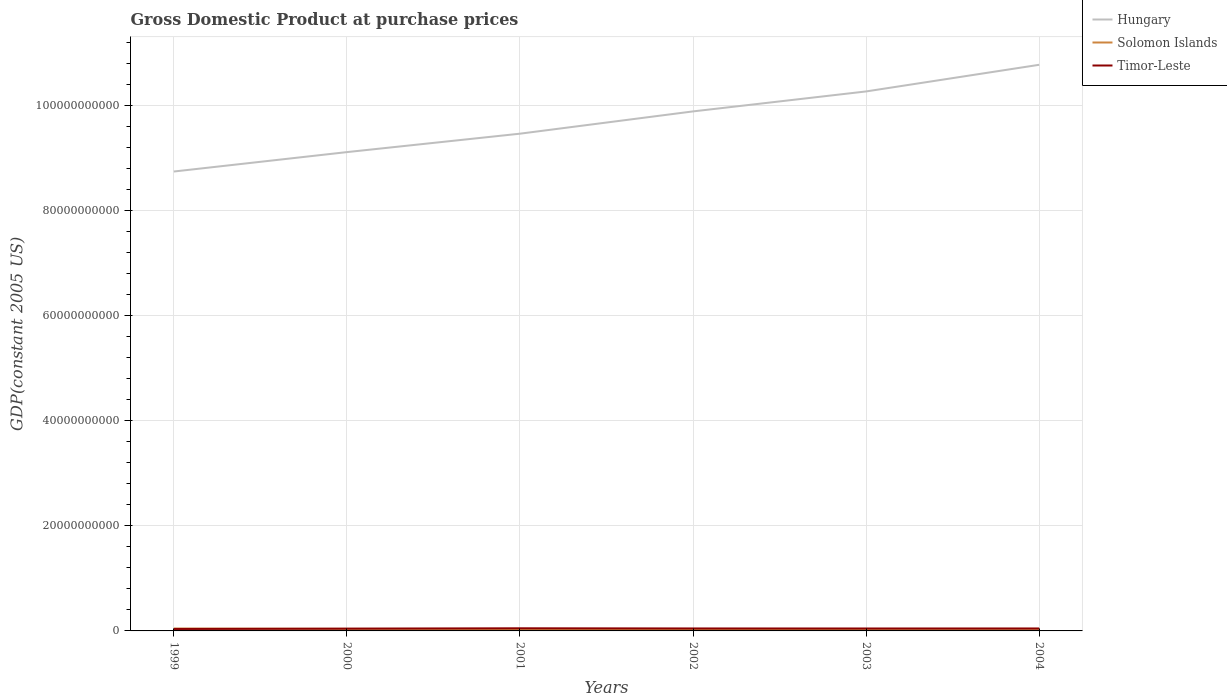Does the line corresponding to Hungary intersect with the line corresponding to Timor-Leste?
Offer a terse response. No. Is the number of lines equal to the number of legend labels?
Provide a succinct answer. Yes. Across all years, what is the maximum GDP at purchase prices in Solomon Islands?
Your answer should be very brief. 3.51e+08. What is the total GDP at purchase prices in Solomon Islands in the graph?
Provide a succinct answer. 1.07e+08. What is the difference between the highest and the second highest GDP at purchase prices in Hungary?
Make the answer very short. 2.03e+1. How many years are there in the graph?
Provide a succinct answer. 6. What is the difference between two consecutive major ticks on the Y-axis?
Ensure brevity in your answer.  2.00e+1. Does the graph contain any zero values?
Provide a succinct answer. No. Where does the legend appear in the graph?
Provide a succinct answer. Top right. How are the legend labels stacked?
Provide a succinct answer. Vertical. What is the title of the graph?
Ensure brevity in your answer.  Gross Domestic Product at purchase prices. What is the label or title of the Y-axis?
Provide a short and direct response. GDP(constant 2005 US). What is the GDP(constant 2005 US) in Hungary in 1999?
Your response must be concise. 8.75e+1. What is the GDP(constant 2005 US) of Solomon Islands in 1999?
Your response must be concise. 4.58e+08. What is the GDP(constant 2005 US) in Timor-Leste in 1999?
Ensure brevity in your answer.  3.69e+08. What is the GDP(constant 2005 US) of Hungary in 2000?
Offer a terse response. 9.12e+1. What is the GDP(constant 2005 US) of Solomon Islands in 2000?
Offer a terse response. 3.93e+08. What is the GDP(constant 2005 US) in Timor-Leste in 2000?
Keep it short and to the point. 4.33e+08. What is the GDP(constant 2005 US) in Hungary in 2001?
Offer a terse response. 9.47e+1. What is the GDP(constant 2005 US) of Solomon Islands in 2001?
Give a very brief answer. 3.62e+08. What is the GDP(constant 2005 US) in Timor-Leste in 2001?
Keep it short and to the point. 5.04e+08. What is the GDP(constant 2005 US) in Hungary in 2002?
Offer a terse response. 9.90e+1. What is the GDP(constant 2005 US) in Solomon Islands in 2002?
Make the answer very short. 3.51e+08. What is the GDP(constant 2005 US) in Timor-Leste in 2002?
Ensure brevity in your answer.  4.71e+08. What is the GDP(constant 2005 US) in Hungary in 2003?
Provide a short and direct response. 1.03e+11. What is the GDP(constant 2005 US) of Solomon Islands in 2003?
Your answer should be compact. 3.74e+08. What is the GDP(constant 2005 US) in Timor-Leste in 2003?
Make the answer very short. 4.60e+08. What is the GDP(constant 2005 US) of Hungary in 2004?
Provide a short and direct response. 1.08e+11. What is the GDP(constant 2005 US) of Solomon Islands in 2004?
Keep it short and to the point. 3.93e+08. What is the GDP(constant 2005 US) in Timor-Leste in 2004?
Make the answer very short. 4.62e+08. Across all years, what is the maximum GDP(constant 2005 US) in Hungary?
Keep it short and to the point. 1.08e+11. Across all years, what is the maximum GDP(constant 2005 US) of Solomon Islands?
Make the answer very short. 4.58e+08. Across all years, what is the maximum GDP(constant 2005 US) in Timor-Leste?
Keep it short and to the point. 5.04e+08. Across all years, what is the minimum GDP(constant 2005 US) in Hungary?
Provide a succinct answer. 8.75e+1. Across all years, what is the minimum GDP(constant 2005 US) in Solomon Islands?
Make the answer very short. 3.51e+08. Across all years, what is the minimum GDP(constant 2005 US) in Timor-Leste?
Provide a short and direct response. 3.69e+08. What is the total GDP(constant 2005 US) of Hungary in the graph?
Give a very brief answer. 5.83e+11. What is the total GDP(constant 2005 US) in Solomon Islands in the graph?
Keep it short and to the point. 2.33e+09. What is the total GDP(constant 2005 US) in Timor-Leste in the graph?
Ensure brevity in your answer.  2.70e+09. What is the difference between the GDP(constant 2005 US) of Hungary in 1999 and that in 2000?
Offer a very short reply. -3.70e+09. What is the difference between the GDP(constant 2005 US) of Solomon Islands in 1999 and that in 2000?
Your answer should be compact. 6.54e+07. What is the difference between the GDP(constant 2005 US) in Timor-Leste in 1999 and that in 2000?
Keep it short and to the point. -6.46e+07. What is the difference between the GDP(constant 2005 US) in Hungary in 1999 and that in 2001?
Offer a very short reply. -7.21e+09. What is the difference between the GDP(constant 2005 US) in Solomon Islands in 1999 and that in 2001?
Offer a terse response. 9.67e+07. What is the difference between the GDP(constant 2005 US) of Timor-Leste in 1999 and that in 2001?
Offer a terse response. -1.35e+08. What is the difference between the GDP(constant 2005 US) in Hungary in 1999 and that in 2002?
Offer a terse response. -1.15e+1. What is the difference between the GDP(constant 2005 US) in Solomon Islands in 1999 and that in 2002?
Your answer should be compact. 1.07e+08. What is the difference between the GDP(constant 2005 US) in Timor-Leste in 1999 and that in 2002?
Your response must be concise. -1.02e+08. What is the difference between the GDP(constant 2005 US) in Hungary in 1999 and that in 2003?
Offer a very short reply. -1.53e+1. What is the difference between the GDP(constant 2005 US) in Solomon Islands in 1999 and that in 2003?
Keep it short and to the point. 8.40e+07. What is the difference between the GDP(constant 2005 US) in Timor-Leste in 1999 and that in 2003?
Ensure brevity in your answer.  -9.11e+07. What is the difference between the GDP(constant 2005 US) of Hungary in 1999 and that in 2004?
Provide a short and direct response. -2.03e+1. What is the difference between the GDP(constant 2005 US) of Solomon Islands in 1999 and that in 2004?
Offer a very short reply. 6.57e+07. What is the difference between the GDP(constant 2005 US) in Timor-Leste in 1999 and that in 2004?
Offer a terse response. -9.34e+07. What is the difference between the GDP(constant 2005 US) of Hungary in 2000 and that in 2001?
Offer a terse response. -3.51e+09. What is the difference between the GDP(constant 2005 US) of Solomon Islands in 2000 and that in 2001?
Your answer should be very brief. 3.13e+07. What is the difference between the GDP(constant 2005 US) in Timor-Leste in 2000 and that in 2001?
Keep it short and to the point. -7.09e+07. What is the difference between the GDP(constant 2005 US) in Hungary in 2000 and that in 2002?
Offer a terse response. -7.75e+09. What is the difference between the GDP(constant 2005 US) in Solomon Islands in 2000 and that in 2002?
Give a very brief answer. 4.15e+07. What is the difference between the GDP(constant 2005 US) of Timor-Leste in 2000 and that in 2002?
Your response must be concise. -3.74e+07. What is the difference between the GDP(constant 2005 US) of Hungary in 2000 and that in 2003?
Offer a terse response. -1.16e+1. What is the difference between the GDP(constant 2005 US) of Solomon Islands in 2000 and that in 2003?
Make the answer very short. 1.86e+07. What is the difference between the GDP(constant 2005 US) in Timor-Leste in 2000 and that in 2003?
Keep it short and to the point. -2.65e+07. What is the difference between the GDP(constant 2005 US) of Hungary in 2000 and that in 2004?
Make the answer very short. -1.66e+1. What is the difference between the GDP(constant 2005 US) of Solomon Islands in 2000 and that in 2004?
Offer a very short reply. 2.95e+05. What is the difference between the GDP(constant 2005 US) in Timor-Leste in 2000 and that in 2004?
Your answer should be very brief. -2.88e+07. What is the difference between the GDP(constant 2005 US) in Hungary in 2001 and that in 2002?
Provide a succinct answer. -4.24e+09. What is the difference between the GDP(constant 2005 US) of Solomon Islands in 2001 and that in 2002?
Give a very brief answer. 1.01e+07. What is the difference between the GDP(constant 2005 US) in Timor-Leste in 2001 and that in 2002?
Provide a short and direct response. 3.35e+07. What is the difference between the GDP(constant 2005 US) of Hungary in 2001 and that in 2003?
Make the answer very short. -8.05e+09. What is the difference between the GDP(constant 2005 US) of Solomon Islands in 2001 and that in 2003?
Your answer should be very brief. -1.27e+07. What is the difference between the GDP(constant 2005 US) of Timor-Leste in 2001 and that in 2003?
Give a very brief answer. 4.44e+07. What is the difference between the GDP(constant 2005 US) in Hungary in 2001 and that in 2004?
Your answer should be compact. -1.31e+1. What is the difference between the GDP(constant 2005 US) in Solomon Islands in 2001 and that in 2004?
Provide a succinct answer. -3.11e+07. What is the difference between the GDP(constant 2005 US) of Timor-Leste in 2001 and that in 2004?
Give a very brief answer. 4.21e+07. What is the difference between the GDP(constant 2005 US) in Hungary in 2002 and that in 2003?
Your response must be concise. -3.80e+09. What is the difference between the GDP(constant 2005 US) in Solomon Islands in 2002 and that in 2003?
Keep it short and to the point. -2.28e+07. What is the difference between the GDP(constant 2005 US) in Timor-Leste in 2002 and that in 2003?
Provide a succinct answer. 1.09e+07. What is the difference between the GDP(constant 2005 US) in Hungary in 2002 and that in 2004?
Make the answer very short. -8.88e+09. What is the difference between the GDP(constant 2005 US) of Solomon Islands in 2002 and that in 2004?
Ensure brevity in your answer.  -4.12e+07. What is the difference between the GDP(constant 2005 US) of Timor-Leste in 2002 and that in 2004?
Offer a very short reply. 8.57e+06. What is the difference between the GDP(constant 2005 US) of Hungary in 2003 and that in 2004?
Your answer should be very brief. -5.07e+09. What is the difference between the GDP(constant 2005 US) of Solomon Islands in 2003 and that in 2004?
Offer a terse response. -1.83e+07. What is the difference between the GDP(constant 2005 US) in Timor-Leste in 2003 and that in 2004?
Ensure brevity in your answer.  -2.34e+06. What is the difference between the GDP(constant 2005 US) in Hungary in 1999 and the GDP(constant 2005 US) in Solomon Islands in 2000?
Your answer should be compact. 8.71e+1. What is the difference between the GDP(constant 2005 US) of Hungary in 1999 and the GDP(constant 2005 US) of Timor-Leste in 2000?
Your answer should be compact. 8.71e+1. What is the difference between the GDP(constant 2005 US) in Solomon Islands in 1999 and the GDP(constant 2005 US) in Timor-Leste in 2000?
Your response must be concise. 2.50e+07. What is the difference between the GDP(constant 2005 US) of Hungary in 1999 and the GDP(constant 2005 US) of Solomon Islands in 2001?
Your answer should be compact. 8.71e+1. What is the difference between the GDP(constant 2005 US) of Hungary in 1999 and the GDP(constant 2005 US) of Timor-Leste in 2001?
Provide a succinct answer. 8.70e+1. What is the difference between the GDP(constant 2005 US) of Solomon Islands in 1999 and the GDP(constant 2005 US) of Timor-Leste in 2001?
Make the answer very short. -4.59e+07. What is the difference between the GDP(constant 2005 US) in Hungary in 1999 and the GDP(constant 2005 US) in Solomon Islands in 2002?
Provide a short and direct response. 8.72e+1. What is the difference between the GDP(constant 2005 US) of Hungary in 1999 and the GDP(constant 2005 US) of Timor-Leste in 2002?
Provide a succinct answer. 8.70e+1. What is the difference between the GDP(constant 2005 US) in Solomon Islands in 1999 and the GDP(constant 2005 US) in Timor-Leste in 2002?
Give a very brief answer. -1.24e+07. What is the difference between the GDP(constant 2005 US) in Hungary in 1999 and the GDP(constant 2005 US) in Solomon Islands in 2003?
Make the answer very short. 8.71e+1. What is the difference between the GDP(constant 2005 US) of Hungary in 1999 and the GDP(constant 2005 US) of Timor-Leste in 2003?
Ensure brevity in your answer.  8.70e+1. What is the difference between the GDP(constant 2005 US) in Solomon Islands in 1999 and the GDP(constant 2005 US) in Timor-Leste in 2003?
Your answer should be compact. -1.51e+06. What is the difference between the GDP(constant 2005 US) in Hungary in 1999 and the GDP(constant 2005 US) in Solomon Islands in 2004?
Offer a very short reply. 8.71e+1. What is the difference between the GDP(constant 2005 US) in Hungary in 1999 and the GDP(constant 2005 US) in Timor-Leste in 2004?
Provide a short and direct response. 8.70e+1. What is the difference between the GDP(constant 2005 US) in Solomon Islands in 1999 and the GDP(constant 2005 US) in Timor-Leste in 2004?
Give a very brief answer. -3.85e+06. What is the difference between the GDP(constant 2005 US) in Hungary in 2000 and the GDP(constant 2005 US) in Solomon Islands in 2001?
Ensure brevity in your answer.  9.08e+1. What is the difference between the GDP(constant 2005 US) of Hungary in 2000 and the GDP(constant 2005 US) of Timor-Leste in 2001?
Ensure brevity in your answer.  9.07e+1. What is the difference between the GDP(constant 2005 US) of Solomon Islands in 2000 and the GDP(constant 2005 US) of Timor-Leste in 2001?
Ensure brevity in your answer.  -1.11e+08. What is the difference between the GDP(constant 2005 US) in Hungary in 2000 and the GDP(constant 2005 US) in Solomon Islands in 2002?
Your response must be concise. 9.09e+1. What is the difference between the GDP(constant 2005 US) in Hungary in 2000 and the GDP(constant 2005 US) in Timor-Leste in 2002?
Your answer should be very brief. 9.07e+1. What is the difference between the GDP(constant 2005 US) in Solomon Islands in 2000 and the GDP(constant 2005 US) in Timor-Leste in 2002?
Make the answer very short. -7.78e+07. What is the difference between the GDP(constant 2005 US) of Hungary in 2000 and the GDP(constant 2005 US) of Solomon Islands in 2003?
Offer a very short reply. 9.08e+1. What is the difference between the GDP(constant 2005 US) in Hungary in 2000 and the GDP(constant 2005 US) in Timor-Leste in 2003?
Ensure brevity in your answer.  9.07e+1. What is the difference between the GDP(constant 2005 US) of Solomon Islands in 2000 and the GDP(constant 2005 US) of Timor-Leste in 2003?
Your response must be concise. -6.69e+07. What is the difference between the GDP(constant 2005 US) of Hungary in 2000 and the GDP(constant 2005 US) of Solomon Islands in 2004?
Provide a short and direct response. 9.08e+1. What is the difference between the GDP(constant 2005 US) of Hungary in 2000 and the GDP(constant 2005 US) of Timor-Leste in 2004?
Provide a short and direct response. 9.07e+1. What is the difference between the GDP(constant 2005 US) in Solomon Islands in 2000 and the GDP(constant 2005 US) in Timor-Leste in 2004?
Your response must be concise. -6.92e+07. What is the difference between the GDP(constant 2005 US) of Hungary in 2001 and the GDP(constant 2005 US) of Solomon Islands in 2002?
Provide a short and direct response. 9.44e+1. What is the difference between the GDP(constant 2005 US) of Hungary in 2001 and the GDP(constant 2005 US) of Timor-Leste in 2002?
Offer a very short reply. 9.42e+1. What is the difference between the GDP(constant 2005 US) of Solomon Islands in 2001 and the GDP(constant 2005 US) of Timor-Leste in 2002?
Provide a short and direct response. -1.09e+08. What is the difference between the GDP(constant 2005 US) in Hungary in 2001 and the GDP(constant 2005 US) in Solomon Islands in 2003?
Ensure brevity in your answer.  9.43e+1. What is the difference between the GDP(constant 2005 US) in Hungary in 2001 and the GDP(constant 2005 US) in Timor-Leste in 2003?
Your answer should be compact. 9.43e+1. What is the difference between the GDP(constant 2005 US) in Solomon Islands in 2001 and the GDP(constant 2005 US) in Timor-Leste in 2003?
Your answer should be very brief. -9.83e+07. What is the difference between the GDP(constant 2005 US) in Hungary in 2001 and the GDP(constant 2005 US) in Solomon Islands in 2004?
Your answer should be compact. 9.43e+1. What is the difference between the GDP(constant 2005 US) in Hungary in 2001 and the GDP(constant 2005 US) in Timor-Leste in 2004?
Provide a short and direct response. 9.43e+1. What is the difference between the GDP(constant 2005 US) of Solomon Islands in 2001 and the GDP(constant 2005 US) of Timor-Leste in 2004?
Offer a terse response. -1.01e+08. What is the difference between the GDP(constant 2005 US) of Hungary in 2002 and the GDP(constant 2005 US) of Solomon Islands in 2003?
Your response must be concise. 9.86e+1. What is the difference between the GDP(constant 2005 US) in Hungary in 2002 and the GDP(constant 2005 US) in Timor-Leste in 2003?
Your answer should be compact. 9.85e+1. What is the difference between the GDP(constant 2005 US) of Solomon Islands in 2002 and the GDP(constant 2005 US) of Timor-Leste in 2003?
Offer a terse response. -1.08e+08. What is the difference between the GDP(constant 2005 US) in Hungary in 2002 and the GDP(constant 2005 US) in Solomon Islands in 2004?
Provide a short and direct response. 9.86e+1. What is the difference between the GDP(constant 2005 US) of Hungary in 2002 and the GDP(constant 2005 US) of Timor-Leste in 2004?
Give a very brief answer. 9.85e+1. What is the difference between the GDP(constant 2005 US) of Solomon Islands in 2002 and the GDP(constant 2005 US) of Timor-Leste in 2004?
Your answer should be very brief. -1.11e+08. What is the difference between the GDP(constant 2005 US) in Hungary in 2003 and the GDP(constant 2005 US) in Solomon Islands in 2004?
Keep it short and to the point. 1.02e+11. What is the difference between the GDP(constant 2005 US) of Hungary in 2003 and the GDP(constant 2005 US) of Timor-Leste in 2004?
Ensure brevity in your answer.  1.02e+11. What is the difference between the GDP(constant 2005 US) in Solomon Islands in 2003 and the GDP(constant 2005 US) in Timor-Leste in 2004?
Ensure brevity in your answer.  -8.79e+07. What is the average GDP(constant 2005 US) of Hungary per year?
Offer a very short reply. 9.72e+1. What is the average GDP(constant 2005 US) of Solomon Islands per year?
Offer a very short reply. 3.89e+08. What is the average GDP(constant 2005 US) in Timor-Leste per year?
Your response must be concise. 4.50e+08. In the year 1999, what is the difference between the GDP(constant 2005 US) in Hungary and GDP(constant 2005 US) in Solomon Islands?
Offer a very short reply. 8.70e+1. In the year 1999, what is the difference between the GDP(constant 2005 US) in Hungary and GDP(constant 2005 US) in Timor-Leste?
Give a very brief answer. 8.71e+1. In the year 1999, what is the difference between the GDP(constant 2005 US) in Solomon Islands and GDP(constant 2005 US) in Timor-Leste?
Offer a terse response. 8.95e+07. In the year 2000, what is the difference between the GDP(constant 2005 US) of Hungary and GDP(constant 2005 US) of Solomon Islands?
Offer a very short reply. 9.08e+1. In the year 2000, what is the difference between the GDP(constant 2005 US) in Hungary and GDP(constant 2005 US) in Timor-Leste?
Provide a succinct answer. 9.08e+1. In the year 2000, what is the difference between the GDP(constant 2005 US) of Solomon Islands and GDP(constant 2005 US) of Timor-Leste?
Your answer should be very brief. -4.04e+07. In the year 2001, what is the difference between the GDP(constant 2005 US) of Hungary and GDP(constant 2005 US) of Solomon Islands?
Provide a short and direct response. 9.44e+1. In the year 2001, what is the difference between the GDP(constant 2005 US) of Hungary and GDP(constant 2005 US) of Timor-Leste?
Provide a succinct answer. 9.42e+1. In the year 2001, what is the difference between the GDP(constant 2005 US) in Solomon Islands and GDP(constant 2005 US) in Timor-Leste?
Provide a succinct answer. -1.43e+08. In the year 2002, what is the difference between the GDP(constant 2005 US) of Hungary and GDP(constant 2005 US) of Solomon Islands?
Make the answer very short. 9.86e+1. In the year 2002, what is the difference between the GDP(constant 2005 US) of Hungary and GDP(constant 2005 US) of Timor-Leste?
Offer a terse response. 9.85e+1. In the year 2002, what is the difference between the GDP(constant 2005 US) in Solomon Islands and GDP(constant 2005 US) in Timor-Leste?
Provide a succinct answer. -1.19e+08. In the year 2003, what is the difference between the GDP(constant 2005 US) of Hungary and GDP(constant 2005 US) of Solomon Islands?
Make the answer very short. 1.02e+11. In the year 2003, what is the difference between the GDP(constant 2005 US) of Hungary and GDP(constant 2005 US) of Timor-Leste?
Make the answer very short. 1.02e+11. In the year 2003, what is the difference between the GDP(constant 2005 US) of Solomon Islands and GDP(constant 2005 US) of Timor-Leste?
Keep it short and to the point. -8.55e+07. In the year 2004, what is the difference between the GDP(constant 2005 US) in Hungary and GDP(constant 2005 US) in Solomon Islands?
Provide a short and direct response. 1.07e+11. In the year 2004, what is the difference between the GDP(constant 2005 US) of Hungary and GDP(constant 2005 US) of Timor-Leste?
Provide a short and direct response. 1.07e+11. In the year 2004, what is the difference between the GDP(constant 2005 US) of Solomon Islands and GDP(constant 2005 US) of Timor-Leste?
Give a very brief answer. -6.95e+07. What is the ratio of the GDP(constant 2005 US) in Hungary in 1999 to that in 2000?
Your response must be concise. 0.96. What is the ratio of the GDP(constant 2005 US) of Solomon Islands in 1999 to that in 2000?
Provide a short and direct response. 1.17. What is the ratio of the GDP(constant 2005 US) of Timor-Leste in 1999 to that in 2000?
Your answer should be very brief. 0.85. What is the ratio of the GDP(constant 2005 US) of Hungary in 1999 to that in 2001?
Your response must be concise. 0.92. What is the ratio of the GDP(constant 2005 US) in Solomon Islands in 1999 to that in 2001?
Your answer should be compact. 1.27. What is the ratio of the GDP(constant 2005 US) in Timor-Leste in 1999 to that in 2001?
Offer a terse response. 0.73. What is the ratio of the GDP(constant 2005 US) in Hungary in 1999 to that in 2002?
Provide a short and direct response. 0.88. What is the ratio of the GDP(constant 2005 US) of Solomon Islands in 1999 to that in 2002?
Ensure brevity in your answer.  1.3. What is the ratio of the GDP(constant 2005 US) in Timor-Leste in 1999 to that in 2002?
Your answer should be very brief. 0.78. What is the ratio of the GDP(constant 2005 US) of Hungary in 1999 to that in 2003?
Your answer should be compact. 0.85. What is the ratio of the GDP(constant 2005 US) of Solomon Islands in 1999 to that in 2003?
Offer a very short reply. 1.22. What is the ratio of the GDP(constant 2005 US) of Timor-Leste in 1999 to that in 2003?
Give a very brief answer. 0.8. What is the ratio of the GDP(constant 2005 US) in Hungary in 1999 to that in 2004?
Offer a terse response. 0.81. What is the ratio of the GDP(constant 2005 US) of Solomon Islands in 1999 to that in 2004?
Provide a succinct answer. 1.17. What is the ratio of the GDP(constant 2005 US) in Timor-Leste in 1999 to that in 2004?
Make the answer very short. 0.8. What is the ratio of the GDP(constant 2005 US) of Hungary in 2000 to that in 2001?
Your response must be concise. 0.96. What is the ratio of the GDP(constant 2005 US) of Solomon Islands in 2000 to that in 2001?
Your answer should be very brief. 1.09. What is the ratio of the GDP(constant 2005 US) of Timor-Leste in 2000 to that in 2001?
Provide a short and direct response. 0.86. What is the ratio of the GDP(constant 2005 US) of Hungary in 2000 to that in 2002?
Your response must be concise. 0.92. What is the ratio of the GDP(constant 2005 US) of Solomon Islands in 2000 to that in 2002?
Your answer should be compact. 1.12. What is the ratio of the GDP(constant 2005 US) of Timor-Leste in 2000 to that in 2002?
Your answer should be very brief. 0.92. What is the ratio of the GDP(constant 2005 US) in Hungary in 2000 to that in 2003?
Make the answer very short. 0.89. What is the ratio of the GDP(constant 2005 US) of Solomon Islands in 2000 to that in 2003?
Your answer should be very brief. 1.05. What is the ratio of the GDP(constant 2005 US) in Timor-Leste in 2000 to that in 2003?
Provide a short and direct response. 0.94. What is the ratio of the GDP(constant 2005 US) in Hungary in 2000 to that in 2004?
Your response must be concise. 0.85. What is the ratio of the GDP(constant 2005 US) of Solomon Islands in 2000 to that in 2004?
Provide a short and direct response. 1. What is the ratio of the GDP(constant 2005 US) in Timor-Leste in 2000 to that in 2004?
Your answer should be compact. 0.94. What is the ratio of the GDP(constant 2005 US) in Hungary in 2001 to that in 2002?
Provide a short and direct response. 0.96. What is the ratio of the GDP(constant 2005 US) in Solomon Islands in 2001 to that in 2002?
Your answer should be very brief. 1.03. What is the ratio of the GDP(constant 2005 US) of Timor-Leste in 2001 to that in 2002?
Make the answer very short. 1.07. What is the ratio of the GDP(constant 2005 US) of Hungary in 2001 to that in 2003?
Provide a succinct answer. 0.92. What is the ratio of the GDP(constant 2005 US) of Solomon Islands in 2001 to that in 2003?
Make the answer very short. 0.97. What is the ratio of the GDP(constant 2005 US) of Timor-Leste in 2001 to that in 2003?
Offer a terse response. 1.1. What is the ratio of the GDP(constant 2005 US) in Hungary in 2001 to that in 2004?
Provide a succinct answer. 0.88. What is the ratio of the GDP(constant 2005 US) in Solomon Islands in 2001 to that in 2004?
Keep it short and to the point. 0.92. What is the ratio of the GDP(constant 2005 US) of Timor-Leste in 2001 to that in 2004?
Your answer should be compact. 1.09. What is the ratio of the GDP(constant 2005 US) in Solomon Islands in 2002 to that in 2003?
Make the answer very short. 0.94. What is the ratio of the GDP(constant 2005 US) in Timor-Leste in 2002 to that in 2003?
Offer a terse response. 1.02. What is the ratio of the GDP(constant 2005 US) of Hungary in 2002 to that in 2004?
Provide a succinct answer. 0.92. What is the ratio of the GDP(constant 2005 US) of Solomon Islands in 2002 to that in 2004?
Keep it short and to the point. 0.9. What is the ratio of the GDP(constant 2005 US) of Timor-Leste in 2002 to that in 2004?
Your answer should be compact. 1.02. What is the ratio of the GDP(constant 2005 US) in Hungary in 2003 to that in 2004?
Give a very brief answer. 0.95. What is the ratio of the GDP(constant 2005 US) of Solomon Islands in 2003 to that in 2004?
Ensure brevity in your answer.  0.95. What is the ratio of the GDP(constant 2005 US) of Timor-Leste in 2003 to that in 2004?
Ensure brevity in your answer.  0.99. What is the difference between the highest and the second highest GDP(constant 2005 US) of Hungary?
Keep it short and to the point. 5.07e+09. What is the difference between the highest and the second highest GDP(constant 2005 US) in Solomon Islands?
Keep it short and to the point. 6.54e+07. What is the difference between the highest and the second highest GDP(constant 2005 US) of Timor-Leste?
Your answer should be compact. 3.35e+07. What is the difference between the highest and the lowest GDP(constant 2005 US) in Hungary?
Offer a terse response. 2.03e+1. What is the difference between the highest and the lowest GDP(constant 2005 US) of Solomon Islands?
Keep it short and to the point. 1.07e+08. What is the difference between the highest and the lowest GDP(constant 2005 US) in Timor-Leste?
Offer a very short reply. 1.35e+08. 